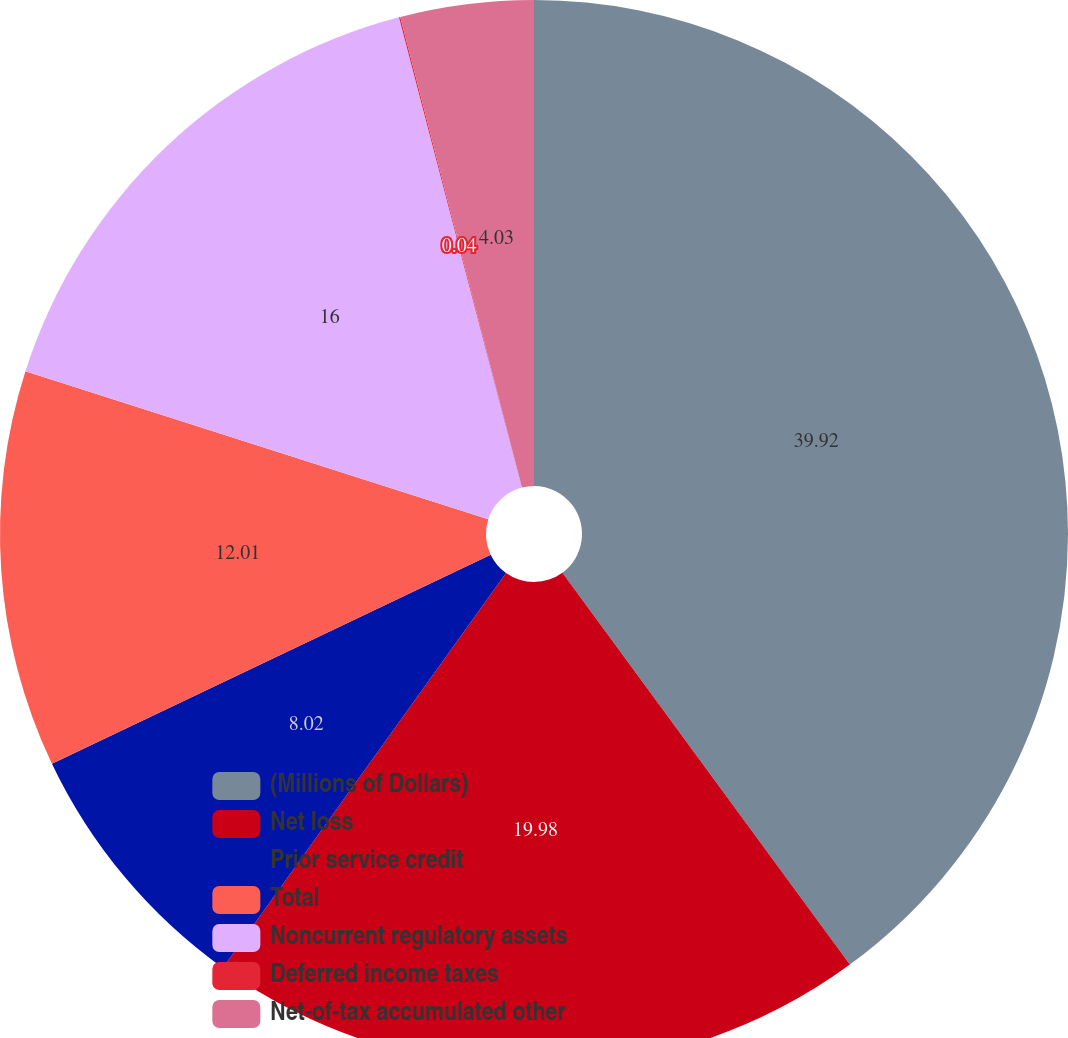<chart> <loc_0><loc_0><loc_500><loc_500><pie_chart><fcel>(Millions of Dollars)<fcel>Net loss<fcel>Prior service credit<fcel>Total<fcel>Noncurrent regulatory assets<fcel>Deferred income taxes<fcel>Net-of-tax accumulated other<nl><fcel>39.93%<fcel>19.98%<fcel>8.02%<fcel>12.01%<fcel>16.0%<fcel>0.04%<fcel>4.03%<nl></chart> 